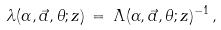<formula> <loc_0><loc_0><loc_500><loc_500>\lambda ( \alpha , \vec { a } , \theta ; z ) \, = \, \Lambda ( \alpha , \vec { a } , \theta ; z ) ^ { - 1 } \, ,</formula> 